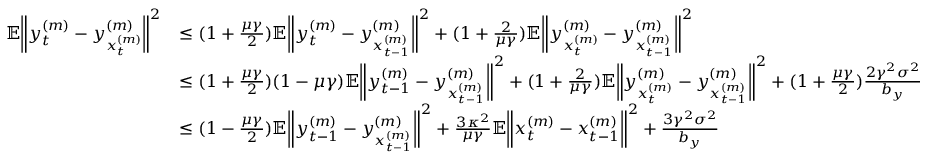<formula> <loc_0><loc_0><loc_500><loc_500>\begin{array} { r l } { \mathbb { E } \left \| y _ { t } ^ { ( m ) } - y _ { x _ { t } ^ { ( m ) } } ^ { ( m ) } \right \| ^ { 2 } } & { \leq ( 1 + \frac { \mu \gamma } { 2 } ) \mathbb { E } \left \| y _ { t } ^ { ( m ) } - y _ { x _ { t - 1 } ^ { ( m ) } } ^ { ( m ) } \right \| ^ { 2 } + ( 1 + \frac { 2 } { \mu \gamma } ) \mathbb { E } \left \| y _ { x _ { t } ^ { ( m ) } } ^ { ( m ) } - y _ { x _ { t - 1 } ^ { ( m ) } } ^ { ( m ) } \right \| ^ { 2 } } \\ & { \leq ( 1 + \frac { \mu \gamma } { 2 } ) ( 1 - \mu \gamma ) \mathbb { E } \left \| y _ { t - 1 } ^ { ( m ) } - y _ { x _ { t - 1 } ^ { ( m ) } } ^ { ( m ) } \right \| ^ { 2 } + ( 1 + \frac { 2 } { \mu \gamma } ) \mathbb { E } \left \| y _ { x _ { t } ^ { ( m ) } } ^ { ( m ) } - y _ { x _ { t - 1 } ^ { ( m ) } } ^ { ( m ) } \right \| ^ { 2 } + ( 1 + \frac { \mu \gamma } { 2 } ) \frac { 2 \gamma ^ { 2 } \sigma ^ { 2 } } { b _ { y } } } \\ & { \leq ( 1 - \frac { \mu \gamma } { 2 } ) \mathbb { E } \left \| y _ { t - 1 } ^ { ( m ) } - y _ { x _ { t - 1 } ^ { ( m ) } } ^ { ( m ) } \right \| ^ { 2 } + \frac { 3 \kappa ^ { 2 } } { \mu \gamma } \mathbb { E } \left \| x _ { t } ^ { ( m ) } - x _ { t - 1 } ^ { ( m ) } \right \| ^ { 2 } + \frac { 3 \gamma ^ { 2 } \sigma ^ { 2 } } { b _ { y } } } \end{array}</formula> 